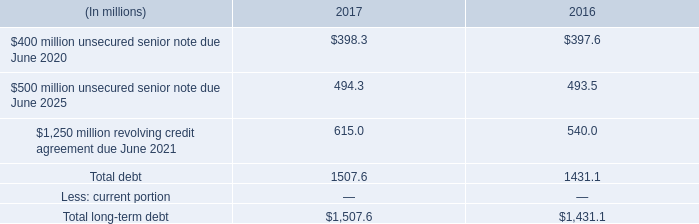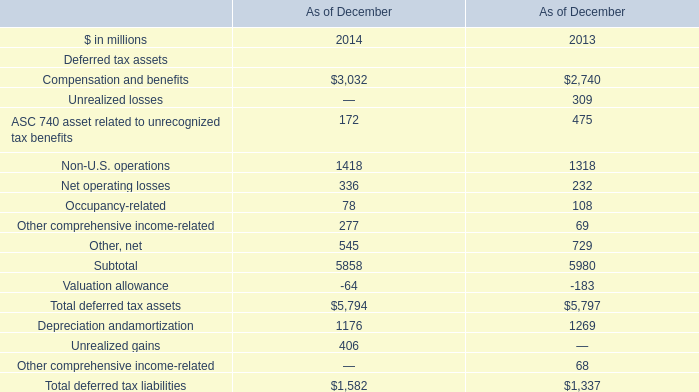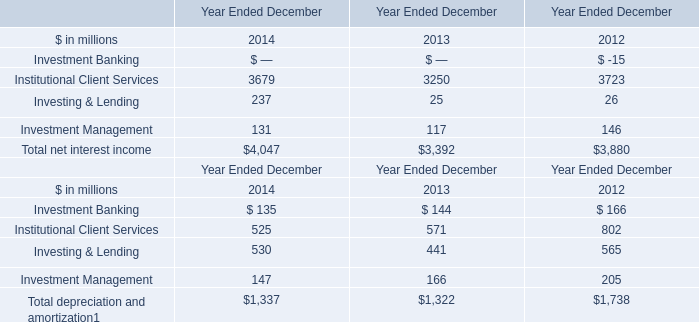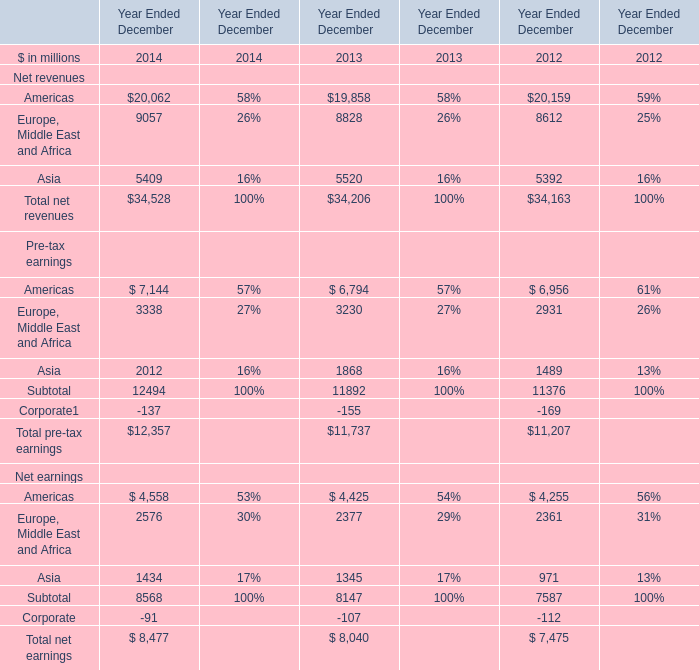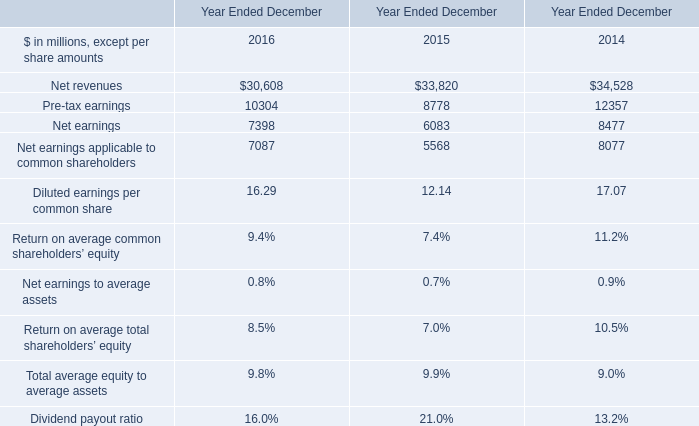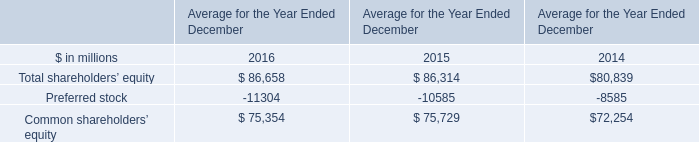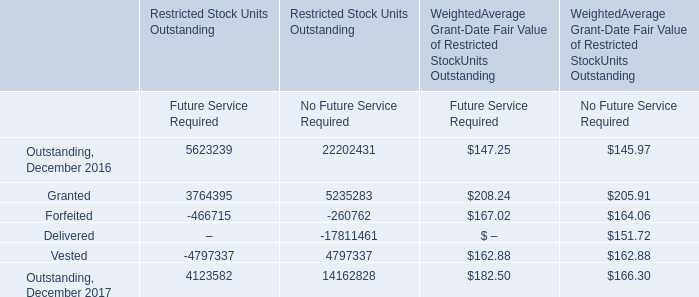What is the amount of Investing & Lending and Investment Management in the year with the most Institutional Client Services (in million) 
Computations: (26 + 146)
Answer: 172.0. 